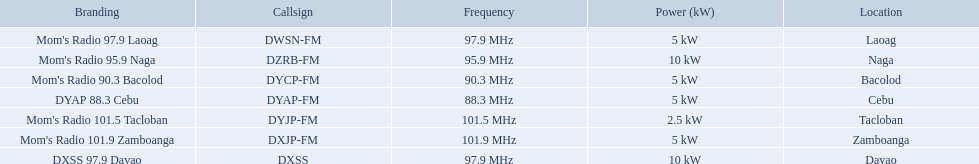What are the frequencies for radios of dyap-fm? 97.9 MHz, 95.9 MHz, 90.3 MHz, 88.3 MHz, 101.5 MHz, 101.9 MHz, 97.9 MHz. What is the lowest frequency? 88.3 MHz. Which radio has this frequency? DYAP 88.3 Cebu. What are the radio frequencies for dyap-fm? 97.9 MHz, 95.9 MHz, 90.3 MHz, 88.3 MHz, 101.5 MHz, 101.9 MHz, 97.9 MHz. What is the minimum frequency? 88.3 MHz. Which radio possesses this frequency? DYAP 88.3 Cebu. What brand names have a 5 kw strength? Mom's Radio 97.9 Laoag, Mom's Radio 90.3 Bacolod, DYAP 88.3 Cebu, Mom's Radio 101.9 Zamboanga. Which one has a call-sign that starts with dy? Mom's Radio 90.3 Bacolod, DYAP 88.3 Cebu. Which among them utilizes the lowest frequency? DYAP 88.3 Cebu. What is the power potential in kw for each unit? 5 kW, 10 kW, 5 kW, 5 kW, 2.5 kW, 5 kW, 10 kW. Which has the lowest? 2.5 kW. What station maintains this power capacity? Mom's Radio 101.5 Tacloban. Which stations are broadcasting on dyap-fm? Mom's Radio 97.9 Laoag, Mom's Radio 95.9 Naga, Mom's Radio 90.3 Bacolod, DYAP 88.3 Cebu, Mom's Radio 101.5 Tacloban, Mom's Radio 101.9 Zamboanga, DXSS 97.9 Davao. From this list, which stations have a power of 5kw or below? Mom's Radio 97.9 Laoag, Mom's Radio 90.3 Bacolod, DYAP 88.3 Cebu, Mom's Radio 101.5 Tacloban, Mom's Radio 101.9 Zamboanga. Among these stations, which one has the lowest broadcasting power? Mom's Radio 101.5 Tacloban. Which brands have a 5 kw power capacity? Mom's Radio 97.9 Laoag, Mom's Radio 90.3 Bacolod, DYAP 88.3 Cebu, Mom's Radio 101.9 Zamboanga. Among these, which one has a call-sign starting with dy? Mom's Radio 90.3 Bacolod, DYAP 88.3 Cebu. Out of those, which operates at the lowest frequency? DYAP 88.3 Cebu. 